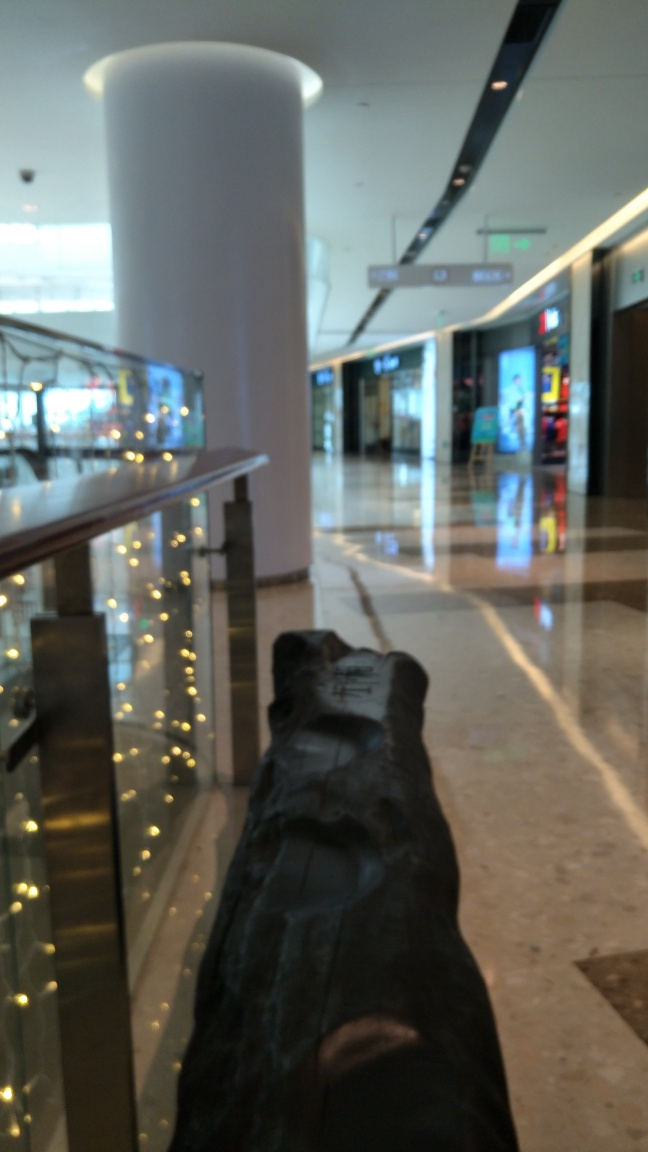Is the contrast well-balanced in this image? No, the contrast in the image appears to be poorly balanced. The foreground is significantly underexposed which results in a loss of detail, while the background, especially the brightly lit areas, seems overexposed, making it difficult to discern clear details throughout. 